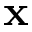Convert formula to latex. <formula><loc_0><loc_0><loc_500><loc_500>x</formula> 